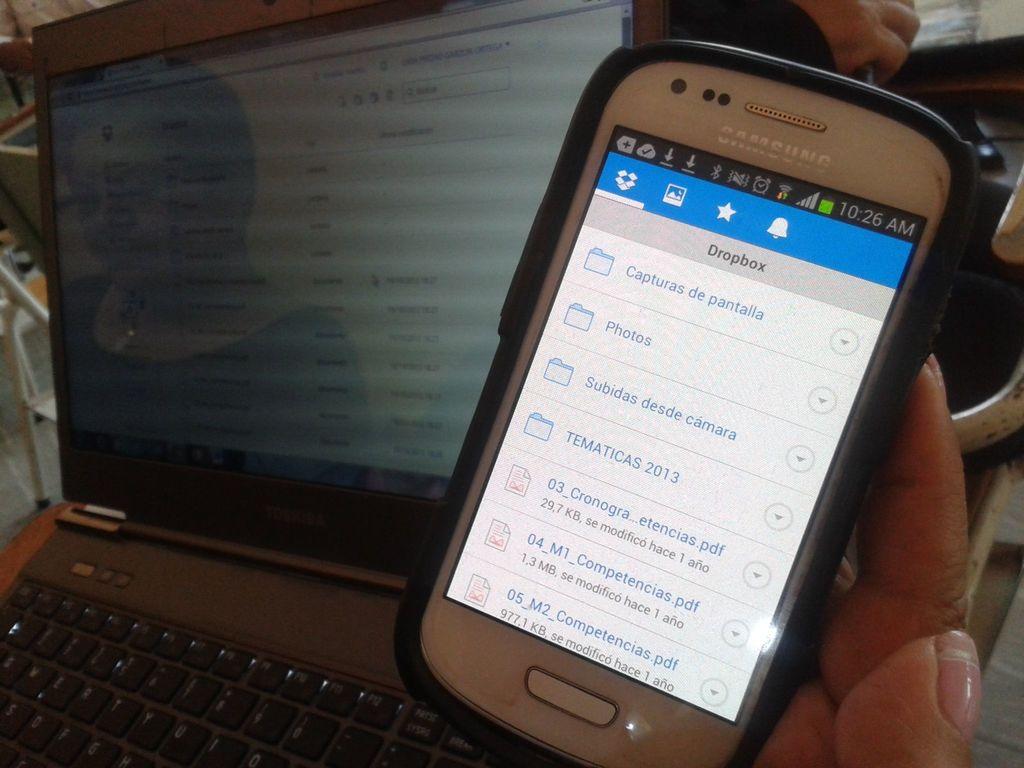What brand of phone is that?
Keep it short and to the point. Samsung. Which app is this person using?
Your response must be concise. Dropbox. 